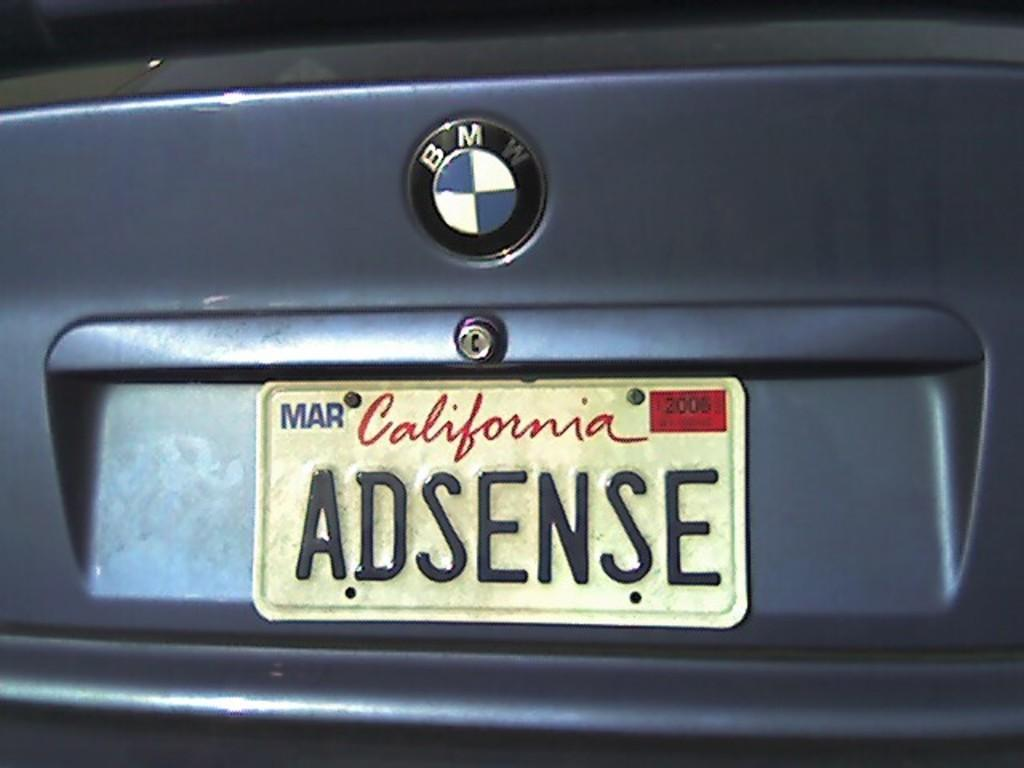<image>
Share a concise interpretation of the image provided. A BMW has a vanity California license plate of their blue car. 